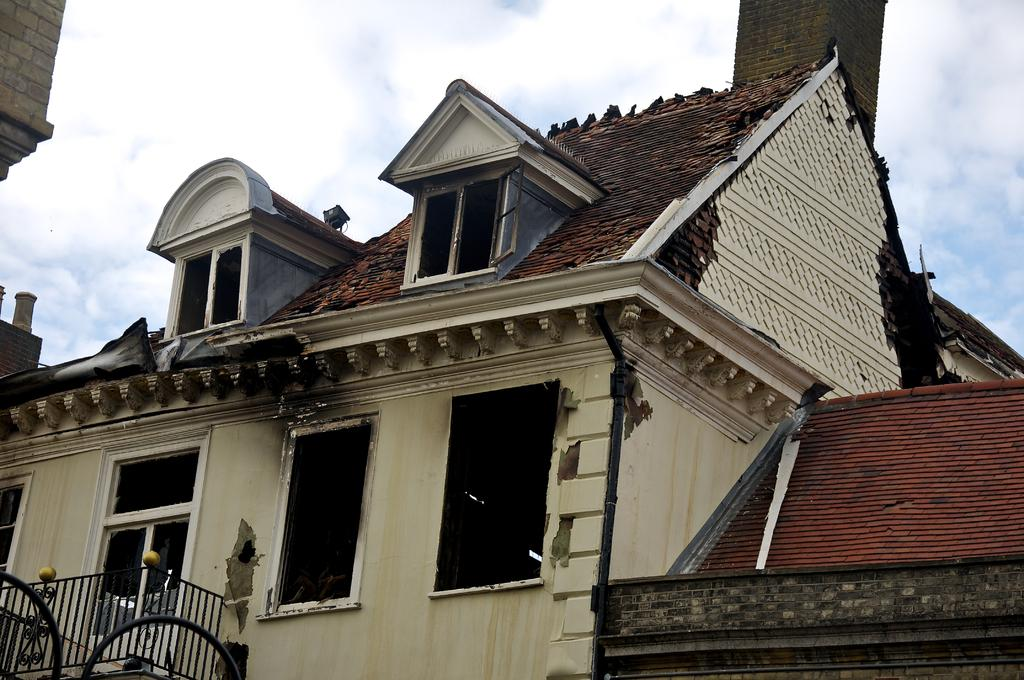What type of structure is present in the image? There is a house in the image. What can be seen in the background of the image? The sky is visible in the background of the image. What type of club does the donkey use for teaching in the image? There is no donkey or club present in the image. The image only features a house and the sky in the background. 